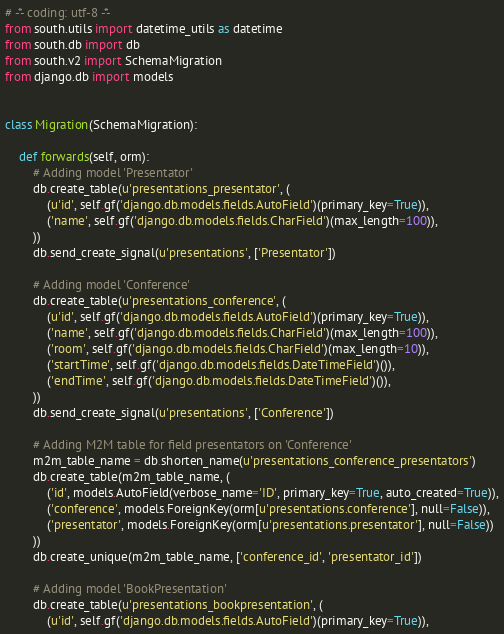<code> <loc_0><loc_0><loc_500><loc_500><_Python_># -*- coding: utf-8 -*-
from south.utils import datetime_utils as datetime
from south.db import db
from south.v2 import SchemaMigration
from django.db import models


class Migration(SchemaMigration):

    def forwards(self, orm):
        # Adding model 'Presentator'
        db.create_table(u'presentations_presentator', (
            (u'id', self.gf('django.db.models.fields.AutoField')(primary_key=True)),
            ('name', self.gf('django.db.models.fields.CharField')(max_length=100)),
        ))
        db.send_create_signal(u'presentations', ['Presentator'])

        # Adding model 'Conference'
        db.create_table(u'presentations_conference', (
            (u'id', self.gf('django.db.models.fields.AutoField')(primary_key=True)),
            ('name', self.gf('django.db.models.fields.CharField')(max_length=100)),
            ('room', self.gf('django.db.models.fields.CharField')(max_length=10)),
            ('startTime', self.gf('django.db.models.fields.DateTimeField')()),
            ('endTime', self.gf('django.db.models.fields.DateTimeField')()),
        ))
        db.send_create_signal(u'presentations', ['Conference'])

        # Adding M2M table for field presentators on 'Conference'
        m2m_table_name = db.shorten_name(u'presentations_conference_presentators')
        db.create_table(m2m_table_name, (
            ('id', models.AutoField(verbose_name='ID', primary_key=True, auto_created=True)),
            ('conference', models.ForeignKey(orm[u'presentations.conference'], null=False)),
            ('presentator', models.ForeignKey(orm[u'presentations.presentator'], null=False))
        ))
        db.create_unique(m2m_table_name, ['conference_id', 'presentator_id'])

        # Adding model 'BookPresentation'
        db.create_table(u'presentations_bookpresentation', (
            (u'id', self.gf('django.db.models.fields.AutoField')(primary_key=True)),</code> 